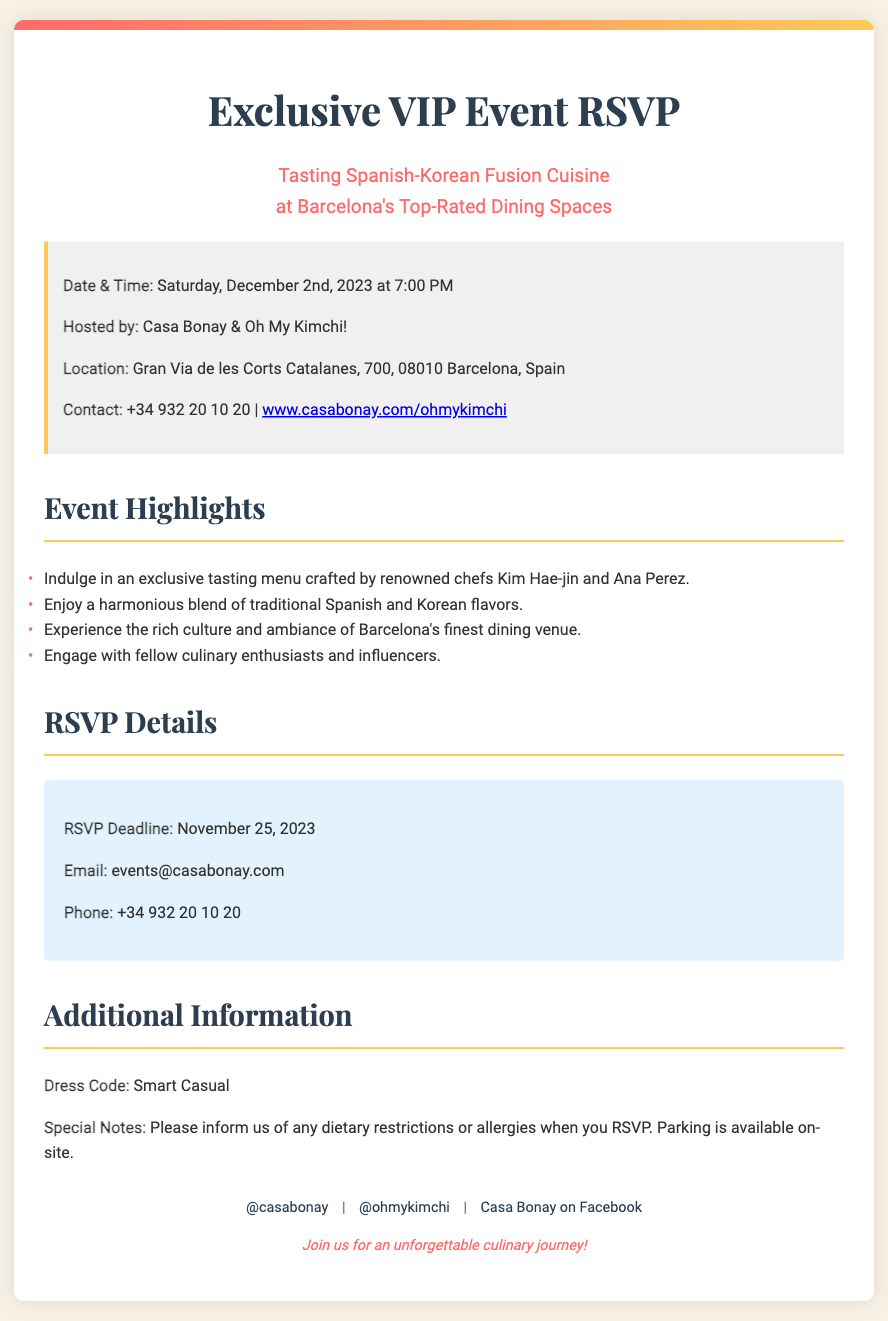what is the date and time of the event? The document specifies the date and time of the event as Saturday, December 2nd, 2023 at 7:00 PM.
Answer: Saturday, December 2nd, 2023 at 7:00 PM who are the hosts of the event? The document mentions that Casa Bonay & Oh My Kimchi! are hosting the event.
Answer: Casa Bonay & Oh My Kimchi! where is the event located? The document provides the location as Gran Via de les Corts Catalanes, 700, 08010 Barcelona, Spain.
Answer: Gran Via de les Corts Catalanes, 700, 08010 Barcelona, Spain what is the RSVP deadline? The document states that the RSVP deadline is November 25, 2023.
Answer: November 25, 2023 what is the dress code for the event? The document includes the dress code as Smart Casual.
Answer: Smart Casual what type of cuisine is being featured at the event? The document specifies that the cuisine featured is Spanish-Korean fusion.
Answer: Spanish-Korean fusion who are the chefs creating the tasting menu? The document lists renowned chefs Kim Hae-jin and Ana Perez as the creators of the tasting menu.
Answer: Kim Hae-jin and Ana Perez what should guests inform when they RSVP? The document asks guests to inform them of any dietary restrictions or allergies.
Answer: dietary restrictions or allergies 